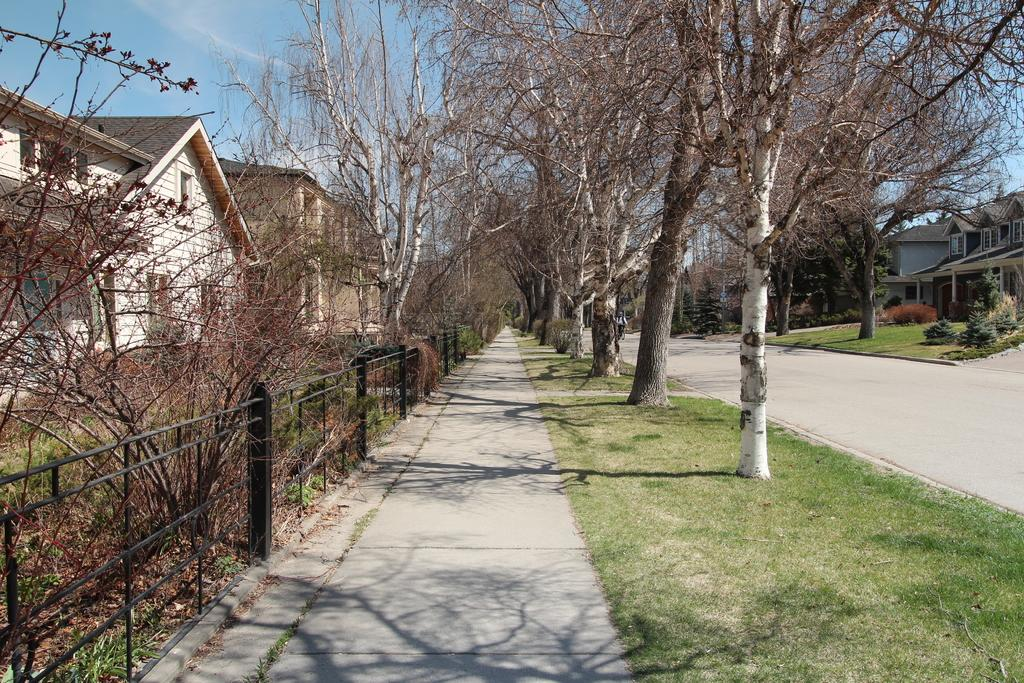What is on the road in the image? There is a vehicle on the road in the image. What type of structures can be seen in the image? There are houses visible in the image. What is the natural environment like in the image? Grass and trees are present in the image. What type of barrier is visible in the image? There is fencing in the image. What type of education can be seen being provided in the image? There is no indication of education being provided in the image. What type of thunder can be heard in the image? There is no sound present in the image, so it is not possible to determine if thunder can be heard. 